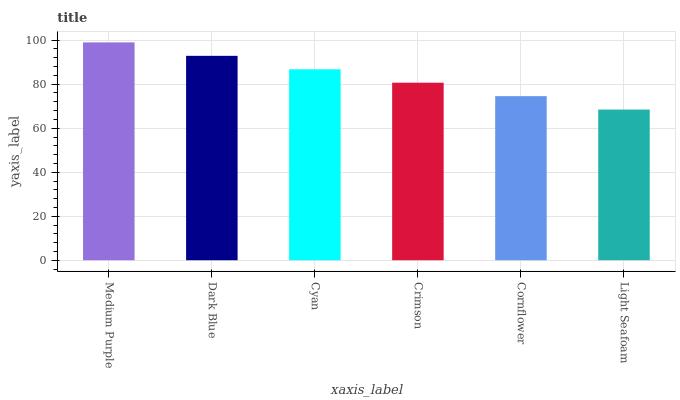Is Light Seafoam the minimum?
Answer yes or no. Yes. Is Medium Purple the maximum?
Answer yes or no. Yes. Is Dark Blue the minimum?
Answer yes or no. No. Is Dark Blue the maximum?
Answer yes or no. No. Is Medium Purple greater than Dark Blue?
Answer yes or no. Yes. Is Dark Blue less than Medium Purple?
Answer yes or no. Yes. Is Dark Blue greater than Medium Purple?
Answer yes or no. No. Is Medium Purple less than Dark Blue?
Answer yes or no. No. Is Cyan the high median?
Answer yes or no. Yes. Is Crimson the low median?
Answer yes or no. Yes. Is Light Seafoam the high median?
Answer yes or no. No. Is Dark Blue the low median?
Answer yes or no. No. 